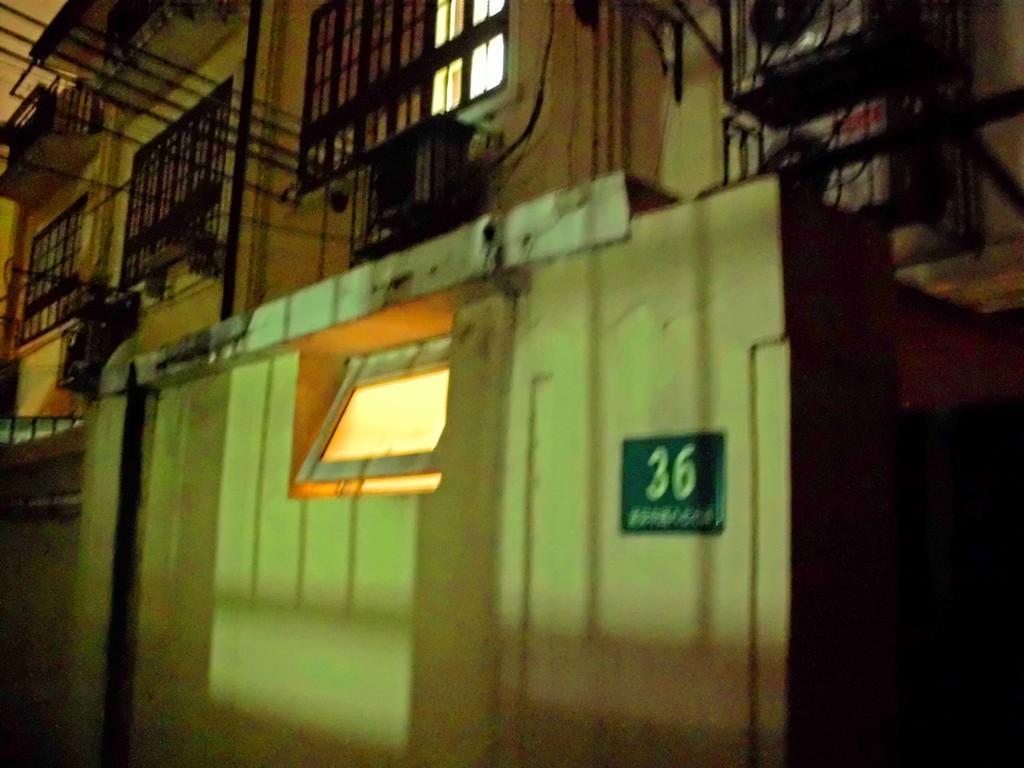How would you summarize this image in a sentence or two? In this image we can see building, small room, windows, mesh gates, wires, air conditioners, a small board on the wall and other objects. 